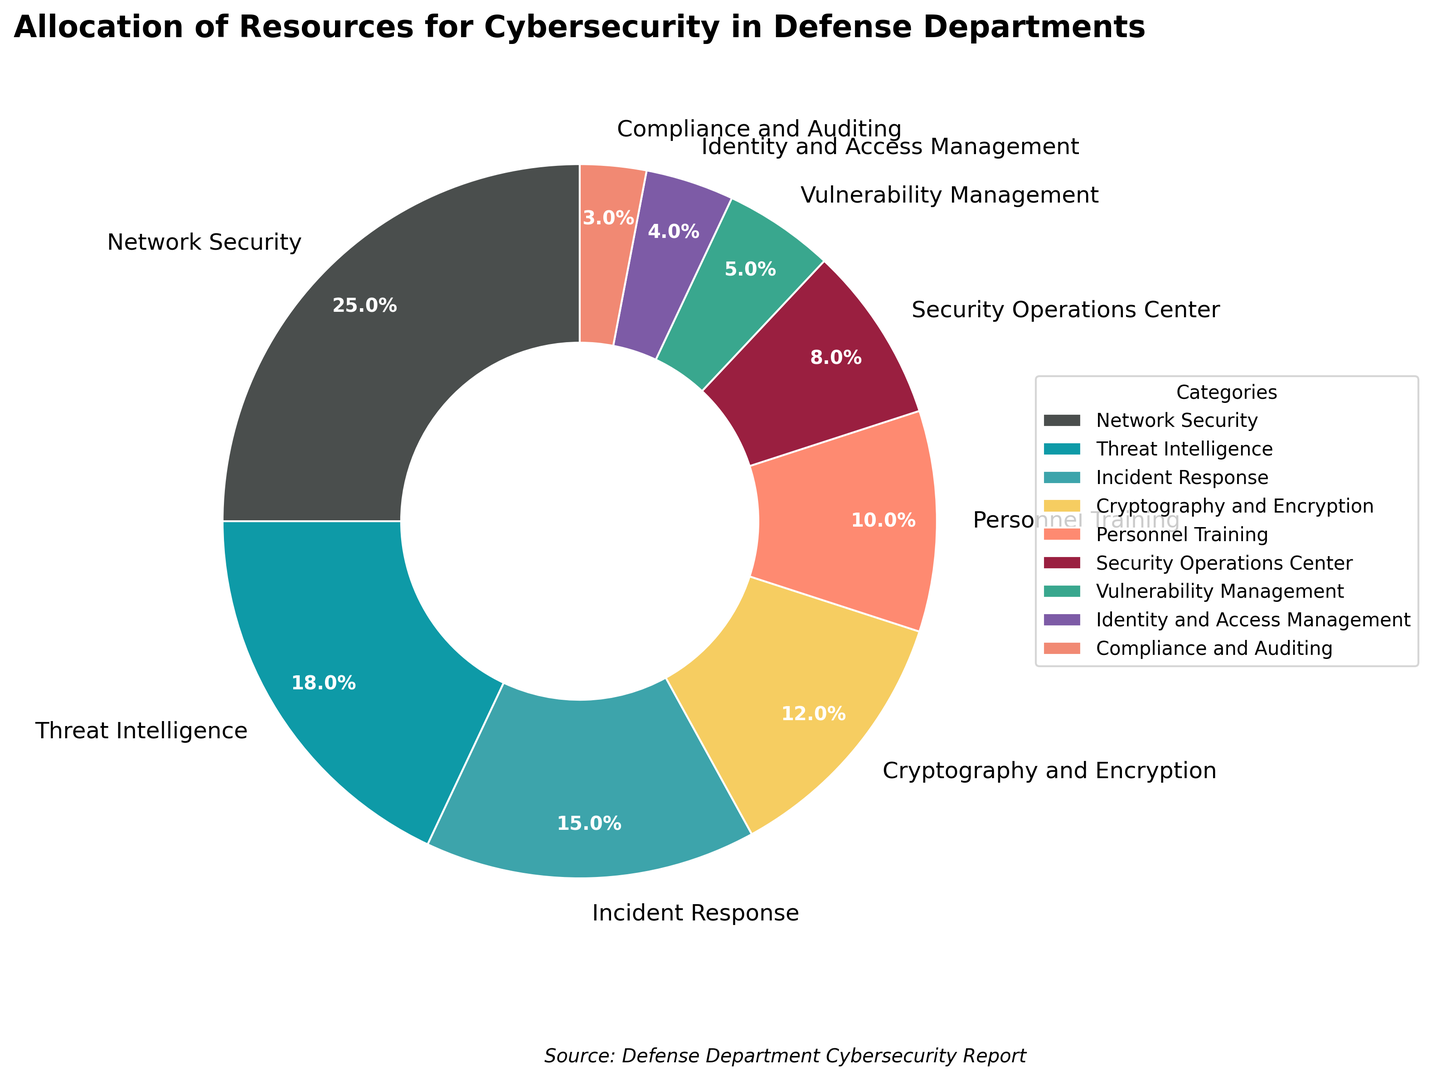What category receives the highest percentage allocation? The pie chart shows various categories for cybersecurity resource allocation. The segment with the largest percentage is labeled "Network Security" with a value of 25%.
Answer: Network Security Which two categories have the closest percentage allocations? Looking at the percentages in the pie chart, "Security Operations Center" (8%) and "Vulnerability Management" (5%) have the closest gap, which is 3%.
Answer: Security Operations Center and Vulnerability Management What is the combined percentage for Threat Intelligence and Incident Response? From the chart, Threat Intelligence is allocated 18% and Incident Response is allocated 15%. Adding these two: 18% + 15% = 33%.
Answer: 33% What is the difference in allocation between Network Security and Cryptography and Encryption? Network Security has an allocation of 25%, while Cryptography and Encryption has 12%. The difference between them is 25% - 12% = 13%.
Answer: 13% How much more percentage is allocated to Personnel Training compared to Compliance and Auditing? Personnel Training has an allocation of 10%, while Compliance and Auditing has 3%. The difference is 10% - 3% = 7%.
Answer: 7% Which category has the third largest allocation? By examining the sizes and labeled percentages in the pie chart, the third largest allocation is Incident Response with 15%.
Answer: Incident Response How do the percentages for Identity and Access Management and Compliance and Auditing compare? Identity and Access Management has 4% and Compliance and Auditing has 3%. Identity and Access Management is 1% higher than Compliance and Auditing.
Answer: Identity and Access Management is 1% higher What is the total percentage allocated to the categories that individually receive less than 10%? Categories less than 10% are: Security Operations Center (8%), Vulnerability Management (5%), Identity and Access Management (4%), and Compliance and Auditing (3%). Adding them: 8% + 5% + 4% + 3% = 20%.
Answer: 20% What is the average percentage allocation across all categories? Summing all percentages from the chart yields 100%. There are 9 categories, so the average is calculated as: 100% / 9 ≈ 11.11%.
Answer: 11.11% Which color represents the Threat Intelligence category? From visually inspecting the colors and labels, Threat Intelligence is represented by a blue-green shade.
Answer: Blue-green 